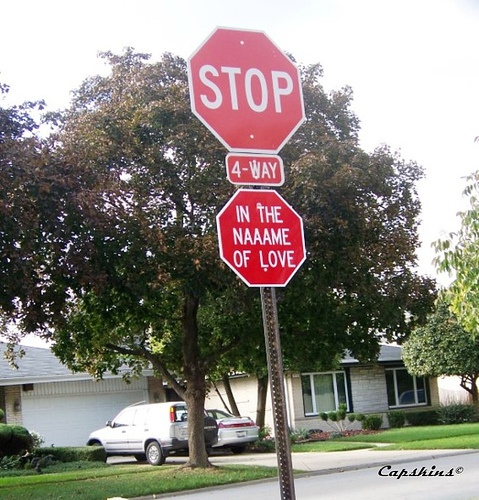Describe the objects in this image and their specific colors. I can see stop sign in white, salmon, lavender, and lightpink tones, car in white, black, darkgray, and gray tones, and car in white, lightgray, darkgray, gray, and black tones in this image. 